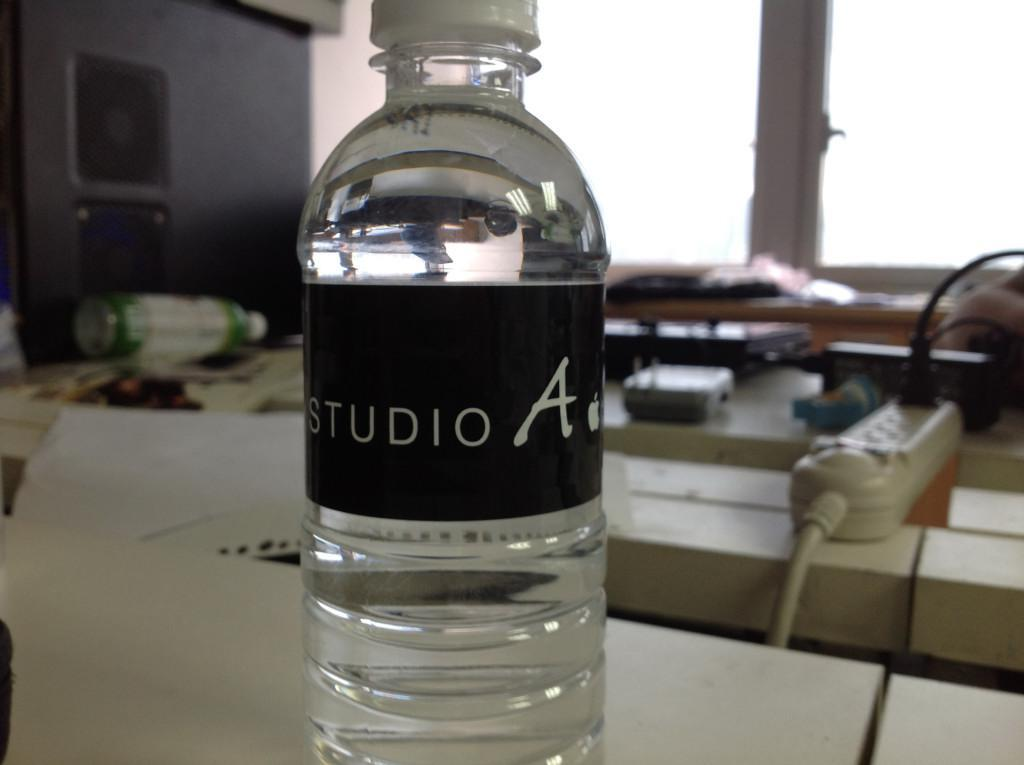Provide a one-sentence caption for the provided image. A bottle of Studio A water sitting on a desk. 